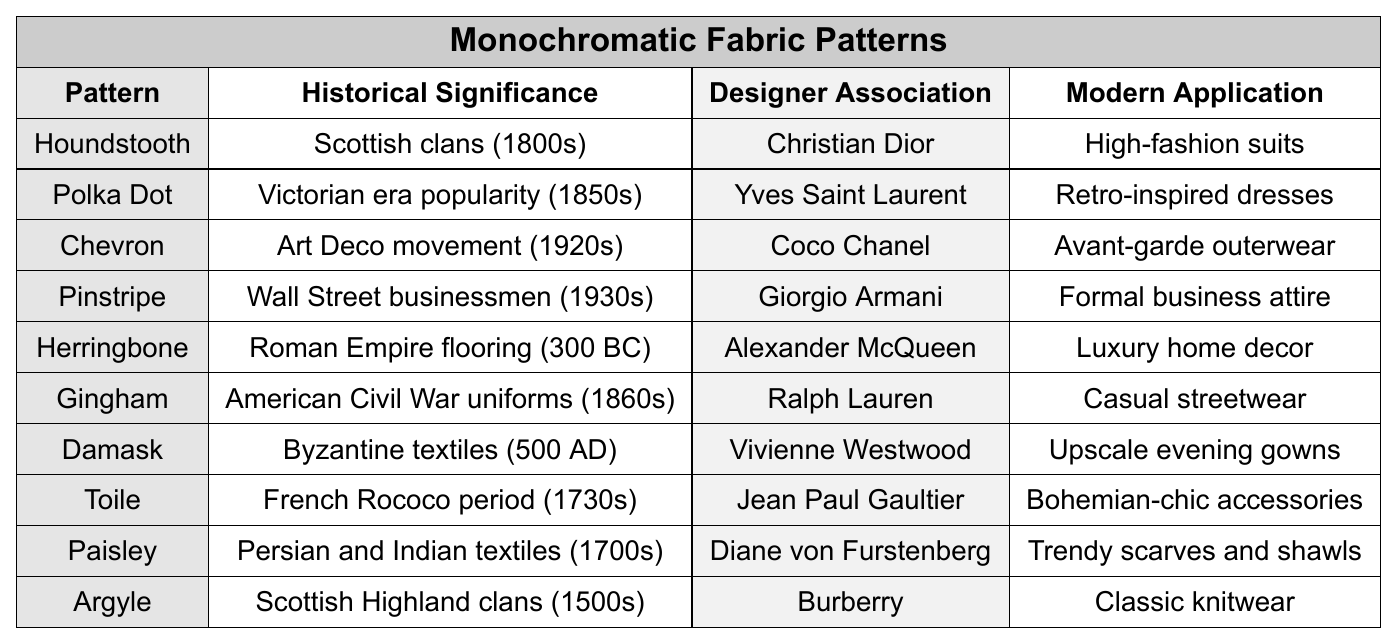What historical significance is associated with the Houndstooth pattern? The table indicates that the Houndstooth pattern is associated with Scottish clans from the 1800s.
Answer: Scottish clans (1800s) Which designer is associated with the Chevron pattern? According to the table, Coco Chanel is linked with the Chevron pattern.
Answer: Coco Chanel What modern application is listed for Polka Dot patterns? Polka Dot patterns are noted in the table as being used for retro-inspired dresses.
Answer: Retro-inspired dresses Which fabric pattern is associated with the American Civil War uniforms? The table shows that Gingham is associated with American Civil War uniforms from the 1860s.
Answer: Gingham Is Argyle associated with any designer in the table? Yes, the table lists Burberry as the designer associated with the Argyle pattern.
Answer: Yes How many fabric patterns are linked to the Rococo period? The table shows that there is one fabric pattern, which is Toile, associated with the French Rococo period (1730s).
Answer: 1 What is the modern application of Damask fabric patterns? The table states that Damask patterns are used for upscale evening gowns.
Answer: Upscale evening gowns Are there any patterns linked to the Victorian era? Yes, the Polka Dot pattern is associated with the Victorian era as noted in the table.
Answer: Yes What is the common theme of the fabrics associated with the 1800s? The table shows Houndstooth and Gingham are both associated with the 1800s indicating a Scottish connection in that period. The connection reflects traditional designs.
Answer: Scottish connection Which pattern has the earliest historical significance listed? The Herringbone pattern is noted in the table to have historical significance tracing back to Roman Empire flooring in 300 BC, making it the earliest.
Answer: Herringbone What is the relationship between Gingham, Ralph Lauren, and casual wear? Gingham is linked in the table with Ralph Lauren, who uses this pattern in casual streetwear designs.
Answer: Gingham is used in casual streetwear by Ralph Lauren 